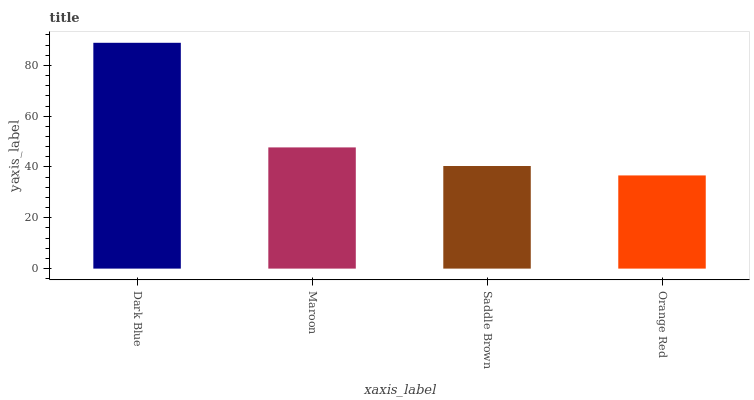Is Orange Red the minimum?
Answer yes or no. Yes. Is Dark Blue the maximum?
Answer yes or no. Yes. Is Maroon the minimum?
Answer yes or no. No. Is Maroon the maximum?
Answer yes or no. No. Is Dark Blue greater than Maroon?
Answer yes or no. Yes. Is Maroon less than Dark Blue?
Answer yes or no. Yes. Is Maroon greater than Dark Blue?
Answer yes or no. No. Is Dark Blue less than Maroon?
Answer yes or no. No. Is Maroon the high median?
Answer yes or no. Yes. Is Saddle Brown the low median?
Answer yes or no. Yes. Is Saddle Brown the high median?
Answer yes or no. No. Is Dark Blue the low median?
Answer yes or no. No. 